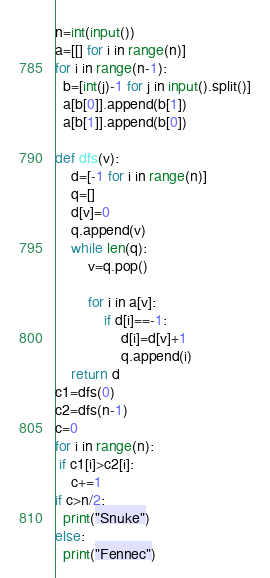<code> <loc_0><loc_0><loc_500><loc_500><_Python_>n=int(input())
a=[[] for i in range(n)]
for i in range(n-1):
  b=[int(j)-1 for j in input().split()]
  a[b[0]].append(b[1])
  a[b[1]].append(b[0])

def dfs(v):
    d=[-1 for i in range(n)]
    q=[]
    d[v]=0
    q.append(v)
    while len(q):
        v=q.pop()
           
        for i in a[v]:
            if d[i]==-1:
                d[i]=d[v]+1
                q.append(i)
    return d
c1=dfs(0)
c2=dfs(n-1)
c=0
for i in range(n):
 if c1[i]>c2[i]:
    c+=1
if c>n/2:
  print("Snuke")
else:
  print("Fennec")
</code> 